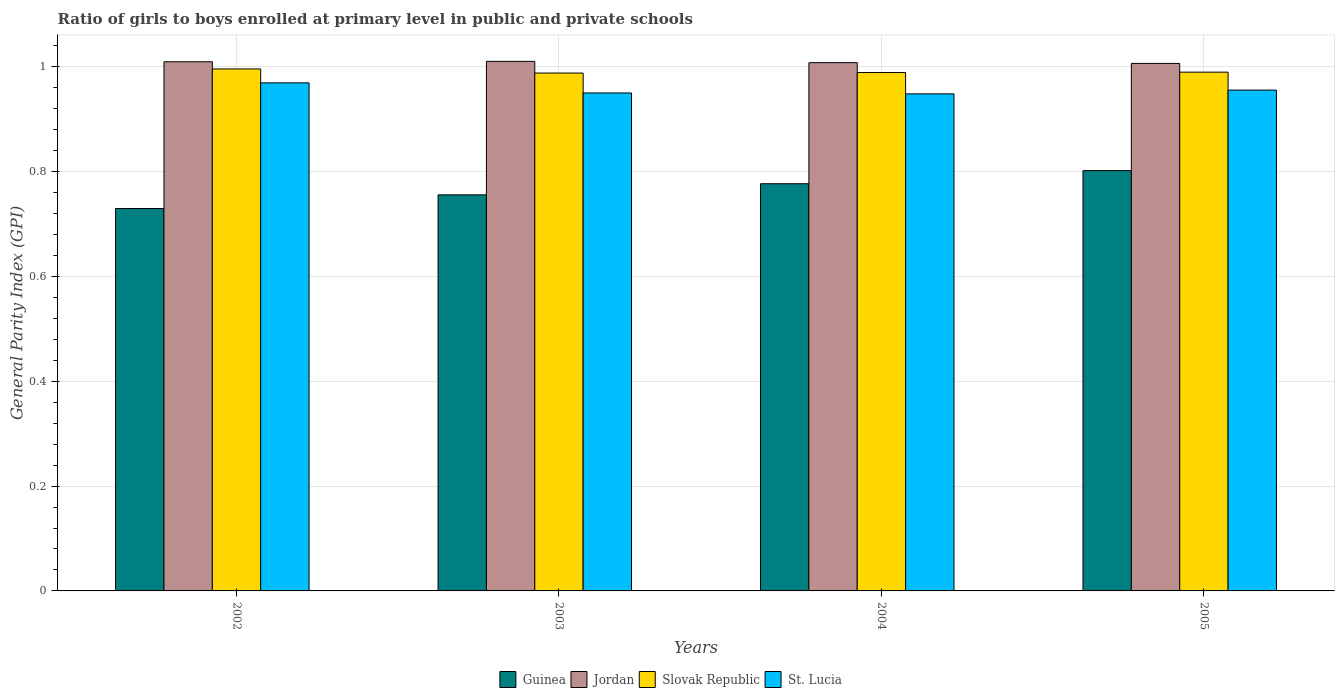How many different coloured bars are there?
Provide a succinct answer. 4. How many groups of bars are there?
Keep it short and to the point. 4. Are the number of bars per tick equal to the number of legend labels?
Ensure brevity in your answer.  Yes. How many bars are there on the 4th tick from the left?
Ensure brevity in your answer.  4. How many bars are there on the 1st tick from the right?
Offer a very short reply. 4. What is the label of the 2nd group of bars from the left?
Offer a very short reply. 2003. In how many cases, is the number of bars for a given year not equal to the number of legend labels?
Make the answer very short. 0. What is the general parity index in Guinea in 2003?
Keep it short and to the point. 0.76. Across all years, what is the maximum general parity index in Slovak Republic?
Your response must be concise. 1. Across all years, what is the minimum general parity index in St. Lucia?
Your response must be concise. 0.95. In which year was the general parity index in St. Lucia minimum?
Provide a succinct answer. 2004. What is the total general parity index in Jordan in the graph?
Offer a terse response. 4.03. What is the difference between the general parity index in Guinea in 2003 and that in 2004?
Give a very brief answer. -0.02. What is the difference between the general parity index in Slovak Republic in 2002 and the general parity index in Jordan in 2004?
Your answer should be compact. -0.01. What is the average general parity index in Guinea per year?
Offer a terse response. 0.77. In the year 2005, what is the difference between the general parity index in Jordan and general parity index in Slovak Republic?
Make the answer very short. 0.02. What is the ratio of the general parity index in St. Lucia in 2002 to that in 2003?
Offer a terse response. 1.02. What is the difference between the highest and the second highest general parity index in Guinea?
Provide a short and direct response. 0.03. What is the difference between the highest and the lowest general parity index in St. Lucia?
Ensure brevity in your answer.  0.02. What does the 4th bar from the left in 2003 represents?
Keep it short and to the point. St. Lucia. What does the 1st bar from the right in 2002 represents?
Your answer should be very brief. St. Lucia. What is the difference between two consecutive major ticks on the Y-axis?
Give a very brief answer. 0.2. Where does the legend appear in the graph?
Your answer should be compact. Bottom center. How many legend labels are there?
Your answer should be compact. 4. How are the legend labels stacked?
Your answer should be very brief. Horizontal. What is the title of the graph?
Make the answer very short. Ratio of girls to boys enrolled at primary level in public and private schools. What is the label or title of the Y-axis?
Make the answer very short. General Parity Index (GPI). What is the General Parity Index (GPI) in Guinea in 2002?
Keep it short and to the point. 0.73. What is the General Parity Index (GPI) of Jordan in 2002?
Keep it short and to the point. 1.01. What is the General Parity Index (GPI) in Slovak Republic in 2002?
Provide a short and direct response. 1. What is the General Parity Index (GPI) of St. Lucia in 2002?
Keep it short and to the point. 0.97. What is the General Parity Index (GPI) in Guinea in 2003?
Your response must be concise. 0.76. What is the General Parity Index (GPI) of Jordan in 2003?
Your answer should be very brief. 1.01. What is the General Parity Index (GPI) in Slovak Republic in 2003?
Offer a very short reply. 0.99. What is the General Parity Index (GPI) of St. Lucia in 2003?
Make the answer very short. 0.95. What is the General Parity Index (GPI) of Guinea in 2004?
Your answer should be compact. 0.78. What is the General Parity Index (GPI) in Jordan in 2004?
Ensure brevity in your answer.  1.01. What is the General Parity Index (GPI) in Slovak Republic in 2004?
Ensure brevity in your answer.  0.99. What is the General Parity Index (GPI) in St. Lucia in 2004?
Your answer should be very brief. 0.95. What is the General Parity Index (GPI) in Guinea in 2005?
Your answer should be compact. 0.8. What is the General Parity Index (GPI) of Jordan in 2005?
Keep it short and to the point. 1.01. What is the General Parity Index (GPI) in Slovak Republic in 2005?
Offer a very short reply. 0.99. What is the General Parity Index (GPI) of St. Lucia in 2005?
Provide a succinct answer. 0.96. Across all years, what is the maximum General Parity Index (GPI) of Guinea?
Make the answer very short. 0.8. Across all years, what is the maximum General Parity Index (GPI) in Jordan?
Keep it short and to the point. 1.01. Across all years, what is the maximum General Parity Index (GPI) in Slovak Republic?
Your answer should be very brief. 1. Across all years, what is the maximum General Parity Index (GPI) of St. Lucia?
Offer a very short reply. 0.97. Across all years, what is the minimum General Parity Index (GPI) of Guinea?
Ensure brevity in your answer.  0.73. Across all years, what is the minimum General Parity Index (GPI) in Jordan?
Give a very brief answer. 1.01. Across all years, what is the minimum General Parity Index (GPI) in Slovak Republic?
Offer a very short reply. 0.99. Across all years, what is the minimum General Parity Index (GPI) in St. Lucia?
Offer a very short reply. 0.95. What is the total General Parity Index (GPI) in Guinea in the graph?
Your answer should be very brief. 3.06. What is the total General Parity Index (GPI) in Jordan in the graph?
Provide a short and direct response. 4.03. What is the total General Parity Index (GPI) in Slovak Republic in the graph?
Keep it short and to the point. 3.96. What is the total General Parity Index (GPI) in St. Lucia in the graph?
Keep it short and to the point. 3.82. What is the difference between the General Parity Index (GPI) of Guinea in 2002 and that in 2003?
Offer a very short reply. -0.03. What is the difference between the General Parity Index (GPI) in Jordan in 2002 and that in 2003?
Your answer should be compact. -0. What is the difference between the General Parity Index (GPI) of Slovak Republic in 2002 and that in 2003?
Ensure brevity in your answer.  0.01. What is the difference between the General Parity Index (GPI) in St. Lucia in 2002 and that in 2003?
Offer a terse response. 0.02. What is the difference between the General Parity Index (GPI) in Guinea in 2002 and that in 2004?
Offer a very short reply. -0.05. What is the difference between the General Parity Index (GPI) of Jordan in 2002 and that in 2004?
Your response must be concise. 0. What is the difference between the General Parity Index (GPI) of Slovak Republic in 2002 and that in 2004?
Your answer should be very brief. 0.01. What is the difference between the General Parity Index (GPI) in St. Lucia in 2002 and that in 2004?
Give a very brief answer. 0.02. What is the difference between the General Parity Index (GPI) of Guinea in 2002 and that in 2005?
Ensure brevity in your answer.  -0.07. What is the difference between the General Parity Index (GPI) of Jordan in 2002 and that in 2005?
Provide a short and direct response. 0. What is the difference between the General Parity Index (GPI) in Slovak Republic in 2002 and that in 2005?
Your answer should be compact. 0.01. What is the difference between the General Parity Index (GPI) of St. Lucia in 2002 and that in 2005?
Give a very brief answer. 0.01. What is the difference between the General Parity Index (GPI) of Guinea in 2003 and that in 2004?
Provide a succinct answer. -0.02. What is the difference between the General Parity Index (GPI) in Jordan in 2003 and that in 2004?
Offer a very short reply. 0. What is the difference between the General Parity Index (GPI) of Slovak Republic in 2003 and that in 2004?
Provide a short and direct response. -0. What is the difference between the General Parity Index (GPI) in St. Lucia in 2003 and that in 2004?
Offer a terse response. 0. What is the difference between the General Parity Index (GPI) of Guinea in 2003 and that in 2005?
Your response must be concise. -0.05. What is the difference between the General Parity Index (GPI) of Jordan in 2003 and that in 2005?
Offer a very short reply. 0. What is the difference between the General Parity Index (GPI) in Slovak Republic in 2003 and that in 2005?
Provide a succinct answer. -0. What is the difference between the General Parity Index (GPI) in St. Lucia in 2003 and that in 2005?
Keep it short and to the point. -0.01. What is the difference between the General Parity Index (GPI) in Guinea in 2004 and that in 2005?
Make the answer very short. -0.03. What is the difference between the General Parity Index (GPI) in Jordan in 2004 and that in 2005?
Ensure brevity in your answer.  0. What is the difference between the General Parity Index (GPI) in Slovak Republic in 2004 and that in 2005?
Make the answer very short. -0. What is the difference between the General Parity Index (GPI) in St. Lucia in 2004 and that in 2005?
Provide a short and direct response. -0.01. What is the difference between the General Parity Index (GPI) of Guinea in 2002 and the General Parity Index (GPI) of Jordan in 2003?
Make the answer very short. -0.28. What is the difference between the General Parity Index (GPI) of Guinea in 2002 and the General Parity Index (GPI) of Slovak Republic in 2003?
Give a very brief answer. -0.26. What is the difference between the General Parity Index (GPI) in Guinea in 2002 and the General Parity Index (GPI) in St. Lucia in 2003?
Provide a short and direct response. -0.22. What is the difference between the General Parity Index (GPI) of Jordan in 2002 and the General Parity Index (GPI) of Slovak Republic in 2003?
Offer a very short reply. 0.02. What is the difference between the General Parity Index (GPI) of Jordan in 2002 and the General Parity Index (GPI) of St. Lucia in 2003?
Ensure brevity in your answer.  0.06. What is the difference between the General Parity Index (GPI) of Slovak Republic in 2002 and the General Parity Index (GPI) of St. Lucia in 2003?
Offer a very short reply. 0.05. What is the difference between the General Parity Index (GPI) in Guinea in 2002 and the General Parity Index (GPI) in Jordan in 2004?
Provide a succinct answer. -0.28. What is the difference between the General Parity Index (GPI) in Guinea in 2002 and the General Parity Index (GPI) in Slovak Republic in 2004?
Keep it short and to the point. -0.26. What is the difference between the General Parity Index (GPI) in Guinea in 2002 and the General Parity Index (GPI) in St. Lucia in 2004?
Offer a terse response. -0.22. What is the difference between the General Parity Index (GPI) of Jordan in 2002 and the General Parity Index (GPI) of Slovak Republic in 2004?
Ensure brevity in your answer.  0.02. What is the difference between the General Parity Index (GPI) of Jordan in 2002 and the General Parity Index (GPI) of St. Lucia in 2004?
Provide a short and direct response. 0.06. What is the difference between the General Parity Index (GPI) in Slovak Republic in 2002 and the General Parity Index (GPI) in St. Lucia in 2004?
Offer a terse response. 0.05. What is the difference between the General Parity Index (GPI) of Guinea in 2002 and the General Parity Index (GPI) of Jordan in 2005?
Provide a short and direct response. -0.28. What is the difference between the General Parity Index (GPI) of Guinea in 2002 and the General Parity Index (GPI) of Slovak Republic in 2005?
Your response must be concise. -0.26. What is the difference between the General Parity Index (GPI) of Guinea in 2002 and the General Parity Index (GPI) of St. Lucia in 2005?
Your answer should be very brief. -0.23. What is the difference between the General Parity Index (GPI) of Jordan in 2002 and the General Parity Index (GPI) of Slovak Republic in 2005?
Your answer should be very brief. 0.02. What is the difference between the General Parity Index (GPI) in Jordan in 2002 and the General Parity Index (GPI) in St. Lucia in 2005?
Offer a terse response. 0.05. What is the difference between the General Parity Index (GPI) of Slovak Republic in 2002 and the General Parity Index (GPI) of St. Lucia in 2005?
Provide a succinct answer. 0.04. What is the difference between the General Parity Index (GPI) of Guinea in 2003 and the General Parity Index (GPI) of Jordan in 2004?
Your response must be concise. -0.25. What is the difference between the General Parity Index (GPI) of Guinea in 2003 and the General Parity Index (GPI) of Slovak Republic in 2004?
Your response must be concise. -0.23. What is the difference between the General Parity Index (GPI) of Guinea in 2003 and the General Parity Index (GPI) of St. Lucia in 2004?
Give a very brief answer. -0.19. What is the difference between the General Parity Index (GPI) of Jordan in 2003 and the General Parity Index (GPI) of Slovak Republic in 2004?
Give a very brief answer. 0.02. What is the difference between the General Parity Index (GPI) in Jordan in 2003 and the General Parity Index (GPI) in St. Lucia in 2004?
Your answer should be very brief. 0.06. What is the difference between the General Parity Index (GPI) in Slovak Republic in 2003 and the General Parity Index (GPI) in St. Lucia in 2004?
Make the answer very short. 0.04. What is the difference between the General Parity Index (GPI) in Guinea in 2003 and the General Parity Index (GPI) in Jordan in 2005?
Make the answer very short. -0.25. What is the difference between the General Parity Index (GPI) in Guinea in 2003 and the General Parity Index (GPI) in Slovak Republic in 2005?
Keep it short and to the point. -0.23. What is the difference between the General Parity Index (GPI) in Guinea in 2003 and the General Parity Index (GPI) in St. Lucia in 2005?
Make the answer very short. -0.2. What is the difference between the General Parity Index (GPI) in Jordan in 2003 and the General Parity Index (GPI) in Slovak Republic in 2005?
Ensure brevity in your answer.  0.02. What is the difference between the General Parity Index (GPI) in Jordan in 2003 and the General Parity Index (GPI) in St. Lucia in 2005?
Your answer should be compact. 0.05. What is the difference between the General Parity Index (GPI) in Slovak Republic in 2003 and the General Parity Index (GPI) in St. Lucia in 2005?
Your response must be concise. 0.03. What is the difference between the General Parity Index (GPI) in Guinea in 2004 and the General Parity Index (GPI) in Jordan in 2005?
Provide a succinct answer. -0.23. What is the difference between the General Parity Index (GPI) in Guinea in 2004 and the General Parity Index (GPI) in Slovak Republic in 2005?
Provide a short and direct response. -0.21. What is the difference between the General Parity Index (GPI) in Guinea in 2004 and the General Parity Index (GPI) in St. Lucia in 2005?
Offer a very short reply. -0.18. What is the difference between the General Parity Index (GPI) in Jordan in 2004 and the General Parity Index (GPI) in Slovak Republic in 2005?
Ensure brevity in your answer.  0.02. What is the difference between the General Parity Index (GPI) in Jordan in 2004 and the General Parity Index (GPI) in St. Lucia in 2005?
Your answer should be very brief. 0.05. What is the difference between the General Parity Index (GPI) of Slovak Republic in 2004 and the General Parity Index (GPI) of St. Lucia in 2005?
Ensure brevity in your answer.  0.03. What is the average General Parity Index (GPI) in Guinea per year?
Your response must be concise. 0.77. What is the average General Parity Index (GPI) of Jordan per year?
Give a very brief answer. 1.01. What is the average General Parity Index (GPI) of St. Lucia per year?
Make the answer very short. 0.96. In the year 2002, what is the difference between the General Parity Index (GPI) of Guinea and General Parity Index (GPI) of Jordan?
Your response must be concise. -0.28. In the year 2002, what is the difference between the General Parity Index (GPI) of Guinea and General Parity Index (GPI) of Slovak Republic?
Offer a very short reply. -0.27. In the year 2002, what is the difference between the General Parity Index (GPI) in Guinea and General Parity Index (GPI) in St. Lucia?
Offer a terse response. -0.24. In the year 2002, what is the difference between the General Parity Index (GPI) in Jordan and General Parity Index (GPI) in Slovak Republic?
Keep it short and to the point. 0.01. In the year 2002, what is the difference between the General Parity Index (GPI) of Jordan and General Parity Index (GPI) of St. Lucia?
Give a very brief answer. 0.04. In the year 2002, what is the difference between the General Parity Index (GPI) in Slovak Republic and General Parity Index (GPI) in St. Lucia?
Your response must be concise. 0.03. In the year 2003, what is the difference between the General Parity Index (GPI) in Guinea and General Parity Index (GPI) in Jordan?
Your answer should be very brief. -0.25. In the year 2003, what is the difference between the General Parity Index (GPI) in Guinea and General Parity Index (GPI) in Slovak Republic?
Your answer should be very brief. -0.23. In the year 2003, what is the difference between the General Parity Index (GPI) in Guinea and General Parity Index (GPI) in St. Lucia?
Provide a succinct answer. -0.19. In the year 2003, what is the difference between the General Parity Index (GPI) in Jordan and General Parity Index (GPI) in Slovak Republic?
Give a very brief answer. 0.02. In the year 2003, what is the difference between the General Parity Index (GPI) of Jordan and General Parity Index (GPI) of St. Lucia?
Provide a short and direct response. 0.06. In the year 2003, what is the difference between the General Parity Index (GPI) in Slovak Republic and General Parity Index (GPI) in St. Lucia?
Give a very brief answer. 0.04. In the year 2004, what is the difference between the General Parity Index (GPI) of Guinea and General Parity Index (GPI) of Jordan?
Offer a very short reply. -0.23. In the year 2004, what is the difference between the General Parity Index (GPI) in Guinea and General Parity Index (GPI) in Slovak Republic?
Keep it short and to the point. -0.21. In the year 2004, what is the difference between the General Parity Index (GPI) in Guinea and General Parity Index (GPI) in St. Lucia?
Keep it short and to the point. -0.17. In the year 2004, what is the difference between the General Parity Index (GPI) of Jordan and General Parity Index (GPI) of Slovak Republic?
Offer a terse response. 0.02. In the year 2004, what is the difference between the General Parity Index (GPI) in Jordan and General Parity Index (GPI) in St. Lucia?
Offer a terse response. 0.06. In the year 2004, what is the difference between the General Parity Index (GPI) in Slovak Republic and General Parity Index (GPI) in St. Lucia?
Offer a very short reply. 0.04. In the year 2005, what is the difference between the General Parity Index (GPI) in Guinea and General Parity Index (GPI) in Jordan?
Provide a short and direct response. -0.2. In the year 2005, what is the difference between the General Parity Index (GPI) in Guinea and General Parity Index (GPI) in Slovak Republic?
Give a very brief answer. -0.19. In the year 2005, what is the difference between the General Parity Index (GPI) in Guinea and General Parity Index (GPI) in St. Lucia?
Give a very brief answer. -0.15. In the year 2005, what is the difference between the General Parity Index (GPI) in Jordan and General Parity Index (GPI) in Slovak Republic?
Your answer should be compact. 0.02. In the year 2005, what is the difference between the General Parity Index (GPI) of Jordan and General Parity Index (GPI) of St. Lucia?
Ensure brevity in your answer.  0.05. In the year 2005, what is the difference between the General Parity Index (GPI) of Slovak Republic and General Parity Index (GPI) of St. Lucia?
Give a very brief answer. 0.03. What is the ratio of the General Parity Index (GPI) of Guinea in 2002 to that in 2003?
Provide a succinct answer. 0.97. What is the ratio of the General Parity Index (GPI) of Jordan in 2002 to that in 2003?
Provide a succinct answer. 1. What is the ratio of the General Parity Index (GPI) of St. Lucia in 2002 to that in 2003?
Provide a succinct answer. 1.02. What is the ratio of the General Parity Index (GPI) in Guinea in 2002 to that in 2004?
Keep it short and to the point. 0.94. What is the ratio of the General Parity Index (GPI) of Slovak Republic in 2002 to that in 2004?
Ensure brevity in your answer.  1.01. What is the ratio of the General Parity Index (GPI) of St. Lucia in 2002 to that in 2004?
Make the answer very short. 1.02. What is the ratio of the General Parity Index (GPI) in Guinea in 2002 to that in 2005?
Ensure brevity in your answer.  0.91. What is the ratio of the General Parity Index (GPI) in Jordan in 2002 to that in 2005?
Give a very brief answer. 1. What is the ratio of the General Parity Index (GPI) of Slovak Republic in 2002 to that in 2005?
Your response must be concise. 1.01. What is the ratio of the General Parity Index (GPI) in St. Lucia in 2002 to that in 2005?
Your answer should be compact. 1.01. What is the ratio of the General Parity Index (GPI) of Guinea in 2003 to that in 2004?
Make the answer very short. 0.97. What is the ratio of the General Parity Index (GPI) of Jordan in 2003 to that in 2004?
Your answer should be compact. 1. What is the ratio of the General Parity Index (GPI) of Guinea in 2003 to that in 2005?
Keep it short and to the point. 0.94. What is the ratio of the General Parity Index (GPI) of Slovak Republic in 2003 to that in 2005?
Ensure brevity in your answer.  1. What is the ratio of the General Parity Index (GPI) in Guinea in 2004 to that in 2005?
Your response must be concise. 0.97. What is the ratio of the General Parity Index (GPI) in Slovak Republic in 2004 to that in 2005?
Make the answer very short. 1. What is the ratio of the General Parity Index (GPI) in St. Lucia in 2004 to that in 2005?
Provide a short and direct response. 0.99. What is the difference between the highest and the second highest General Parity Index (GPI) of Guinea?
Keep it short and to the point. 0.03. What is the difference between the highest and the second highest General Parity Index (GPI) in Jordan?
Make the answer very short. 0. What is the difference between the highest and the second highest General Parity Index (GPI) of Slovak Republic?
Your answer should be very brief. 0.01. What is the difference between the highest and the second highest General Parity Index (GPI) in St. Lucia?
Offer a very short reply. 0.01. What is the difference between the highest and the lowest General Parity Index (GPI) of Guinea?
Provide a short and direct response. 0.07. What is the difference between the highest and the lowest General Parity Index (GPI) in Jordan?
Your answer should be compact. 0. What is the difference between the highest and the lowest General Parity Index (GPI) of Slovak Republic?
Offer a very short reply. 0.01. What is the difference between the highest and the lowest General Parity Index (GPI) in St. Lucia?
Offer a terse response. 0.02. 